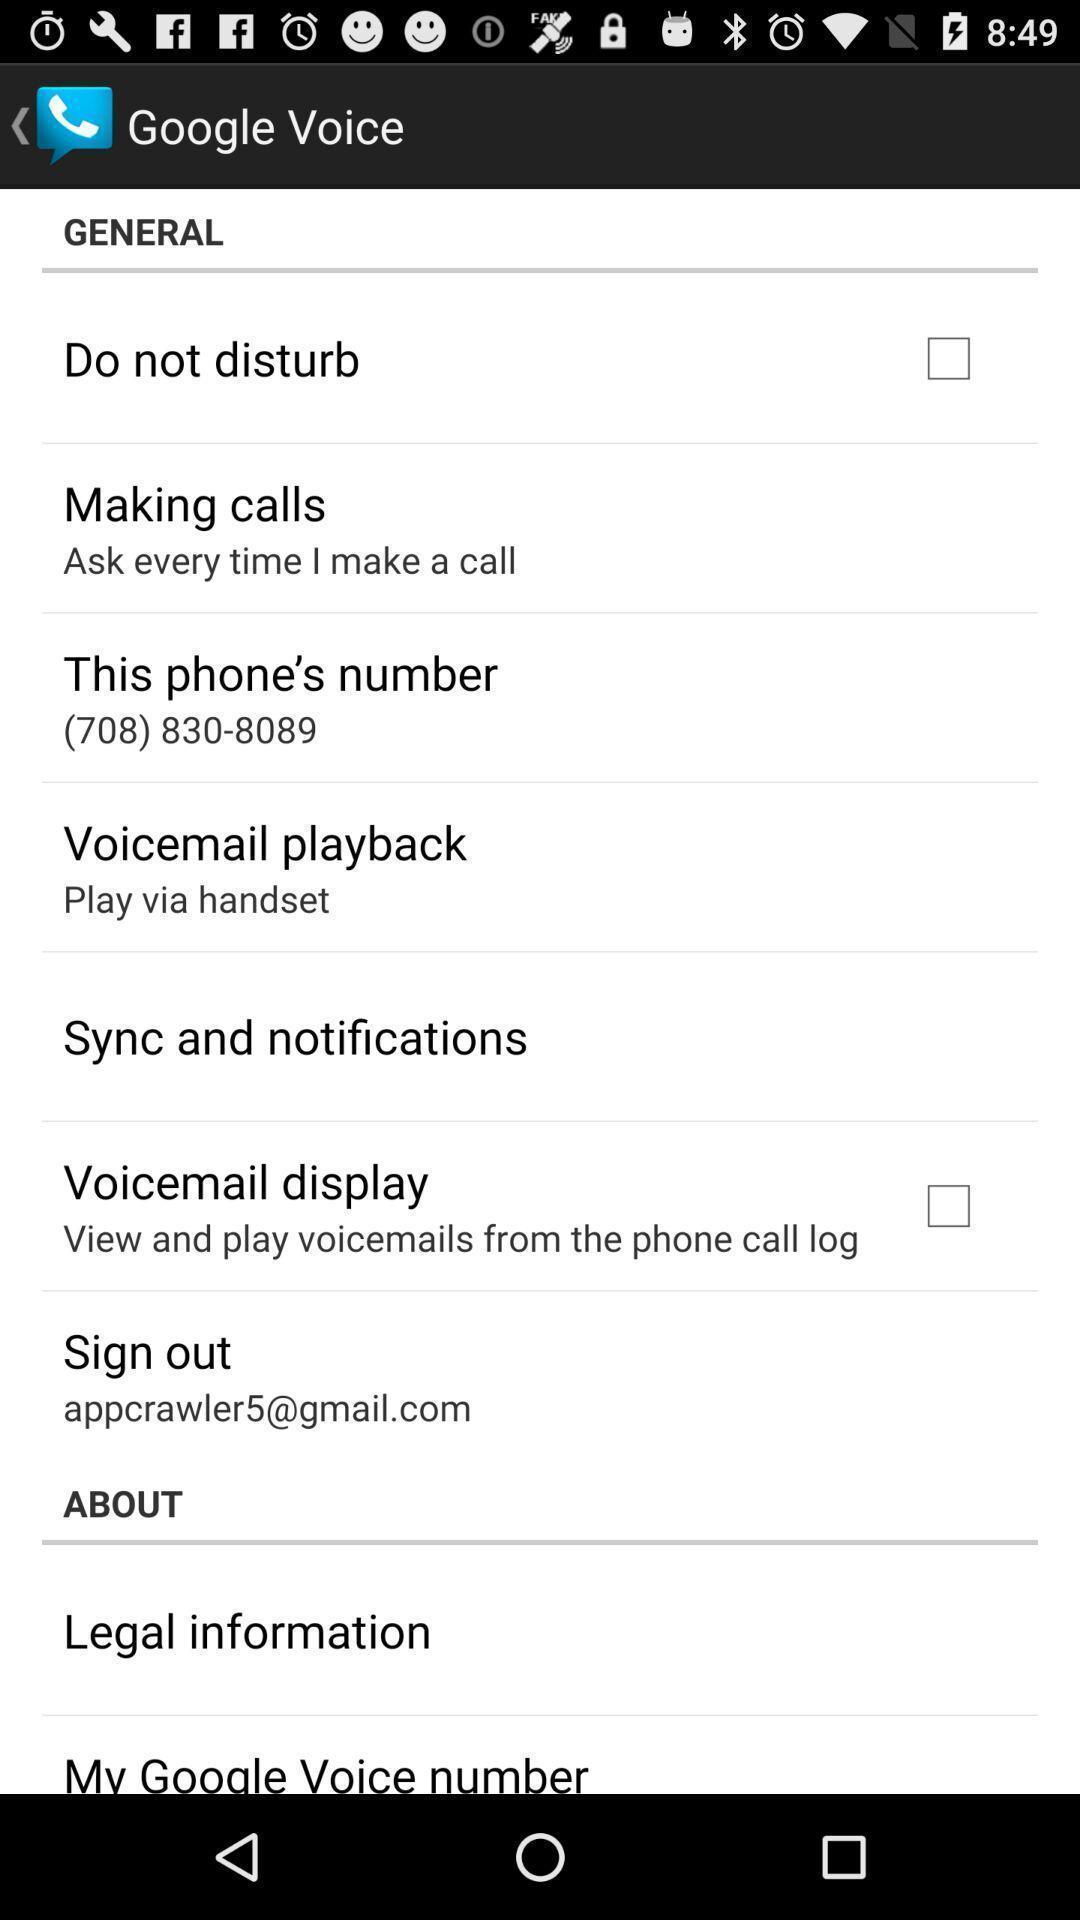Give me a summary of this screen capture. Screen showing general settings page. 